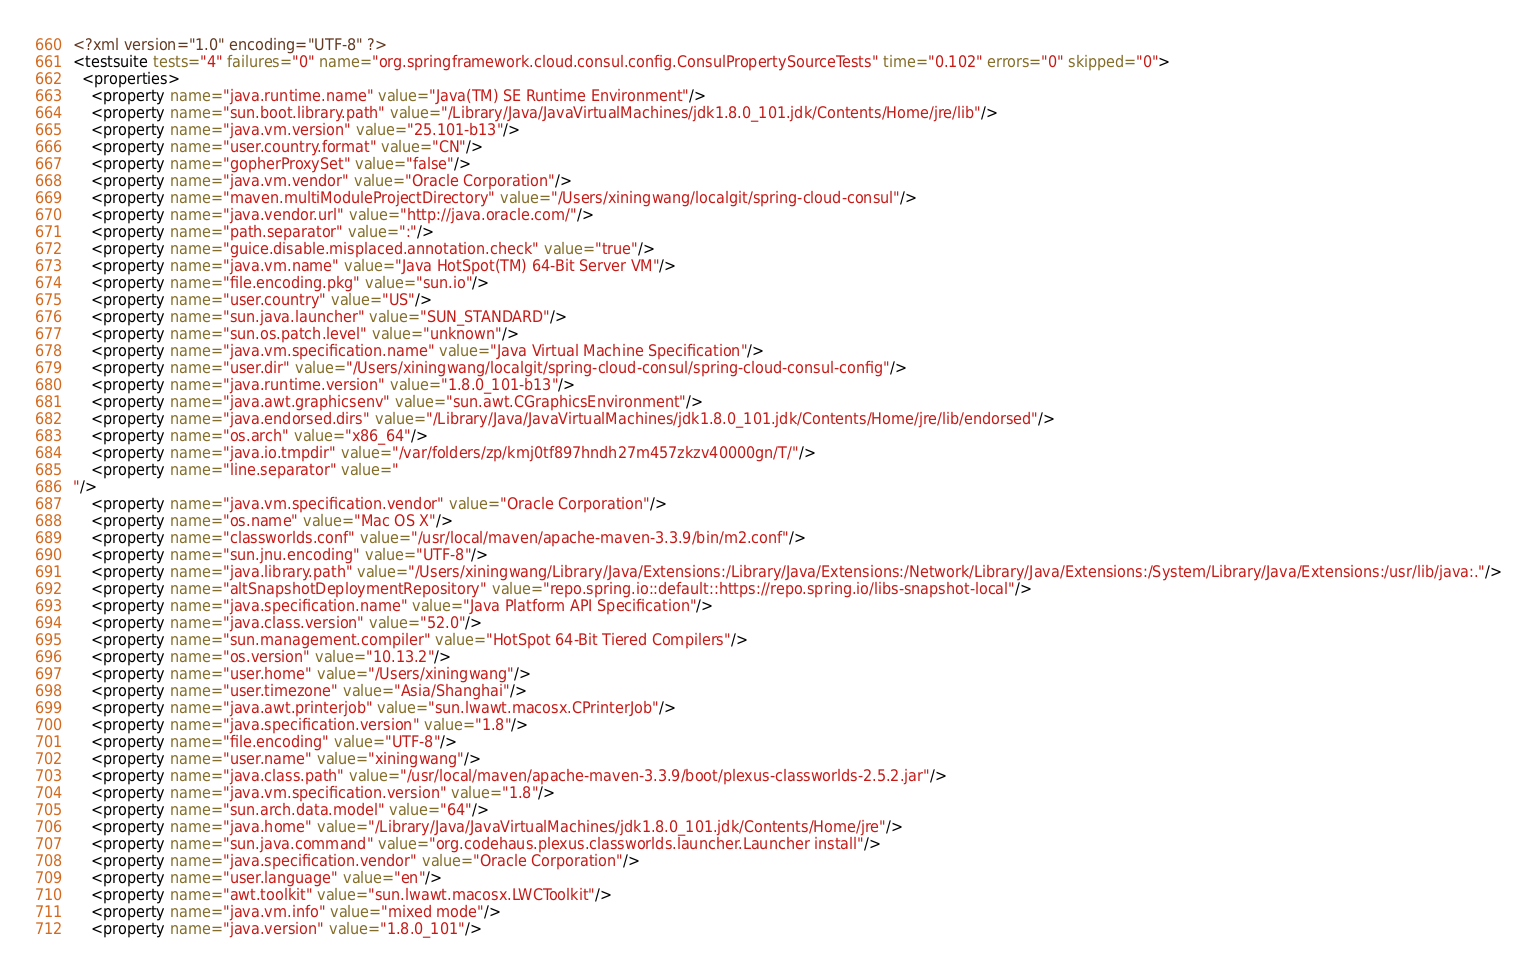<code> <loc_0><loc_0><loc_500><loc_500><_XML_><?xml version="1.0" encoding="UTF-8" ?>
<testsuite tests="4" failures="0" name="org.springframework.cloud.consul.config.ConsulPropertySourceTests" time="0.102" errors="0" skipped="0">
  <properties>
    <property name="java.runtime.name" value="Java(TM) SE Runtime Environment"/>
    <property name="sun.boot.library.path" value="/Library/Java/JavaVirtualMachines/jdk1.8.0_101.jdk/Contents/Home/jre/lib"/>
    <property name="java.vm.version" value="25.101-b13"/>
    <property name="user.country.format" value="CN"/>
    <property name="gopherProxySet" value="false"/>
    <property name="java.vm.vendor" value="Oracle Corporation"/>
    <property name="maven.multiModuleProjectDirectory" value="/Users/xiningwang/localgit/spring-cloud-consul"/>
    <property name="java.vendor.url" value="http://java.oracle.com/"/>
    <property name="path.separator" value=":"/>
    <property name="guice.disable.misplaced.annotation.check" value="true"/>
    <property name="java.vm.name" value="Java HotSpot(TM) 64-Bit Server VM"/>
    <property name="file.encoding.pkg" value="sun.io"/>
    <property name="user.country" value="US"/>
    <property name="sun.java.launcher" value="SUN_STANDARD"/>
    <property name="sun.os.patch.level" value="unknown"/>
    <property name="java.vm.specification.name" value="Java Virtual Machine Specification"/>
    <property name="user.dir" value="/Users/xiningwang/localgit/spring-cloud-consul/spring-cloud-consul-config"/>
    <property name="java.runtime.version" value="1.8.0_101-b13"/>
    <property name="java.awt.graphicsenv" value="sun.awt.CGraphicsEnvironment"/>
    <property name="java.endorsed.dirs" value="/Library/Java/JavaVirtualMachines/jdk1.8.0_101.jdk/Contents/Home/jre/lib/endorsed"/>
    <property name="os.arch" value="x86_64"/>
    <property name="java.io.tmpdir" value="/var/folders/zp/kmj0tf897hndh27m457zkzv40000gn/T/"/>
    <property name="line.separator" value="
"/>
    <property name="java.vm.specification.vendor" value="Oracle Corporation"/>
    <property name="os.name" value="Mac OS X"/>
    <property name="classworlds.conf" value="/usr/local/maven/apache-maven-3.3.9/bin/m2.conf"/>
    <property name="sun.jnu.encoding" value="UTF-8"/>
    <property name="java.library.path" value="/Users/xiningwang/Library/Java/Extensions:/Library/Java/Extensions:/Network/Library/Java/Extensions:/System/Library/Java/Extensions:/usr/lib/java:."/>
    <property name="altSnapshotDeploymentRepository" value="repo.spring.io::default::https://repo.spring.io/libs-snapshot-local"/>
    <property name="java.specification.name" value="Java Platform API Specification"/>
    <property name="java.class.version" value="52.0"/>
    <property name="sun.management.compiler" value="HotSpot 64-Bit Tiered Compilers"/>
    <property name="os.version" value="10.13.2"/>
    <property name="user.home" value="/Users/xiningwang"/>
    <property name="user.timezone" value="Asia/Shanghai"/>
    <property name="java.awt.printerjob" value="sun.lwawt.macosx.CPrinterJob"/>
    <property name="java.specification.version" value="1.8"/>
    <property name="file.encoding" value="UTF-8"/>
    <property name="user.name" value="xiningwang"/>
    <property name="java.class.path" value="/usr/local/maven/apache-maven-3.3.9/boot/plexus-classworlds-2.5.2.jar"/>
    <property name="java.vm.specification.version" value="1.8"/>
    <property name="sun.arch.data.model" value="64"/>
    <property name="java.home" value="/Library/Java/JavaVirtualMachines/jdk1.8.0_101.jdk/Contents/Home/jre"/>
    <property name="sun.java.command" value="org.codehaus.plexus.classworlds.launcher.Launcher install"/>
    <property name="java.specification.vendor" value="Oracle Corporation"/>
    <property name="user.language" value="en"/>
    <property name="awt.toolkit" value="sun.lwawt.macosx.LWCToolkit"/>
    <property name="java.vm.info" value="mixed mode"/>
    <property name="java.version" value="1.8.0_101"/></code> 